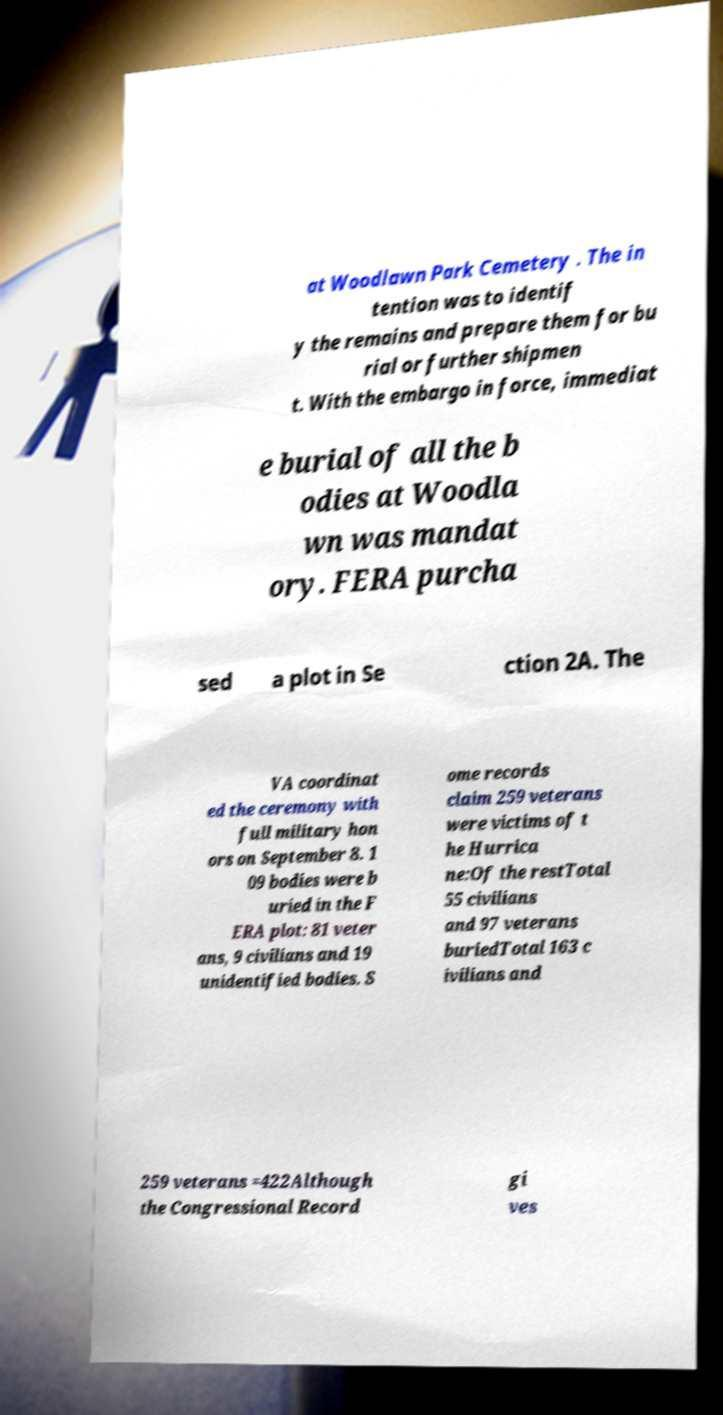For documentation purposes, I need the text within this image transcribed. Could you provide that? at Woodlawn Park Cemetery . The in tention was to identif y the remains and prepare them for bu rial or further shipmen t. With the embargo in force, immediat e burial of all the b odies at Woodla wn was mandat ory. FERA purcha sed a plot in Se ction 2A. The VA coordinat ed the ceremony with full military hon ors on September 8. 1 09 bodies were b uried in the F ERA plot: 81 veter ans, 9 civilians and 19 unidentified bodies. S ome records claim 259 veterans were victims of t he Hurrica ne:Of the restTotal 55 civilians and 97 veterans buriedTotal 163 c ivilians and 259 veterans =422Although the Congressional Record gi ves 